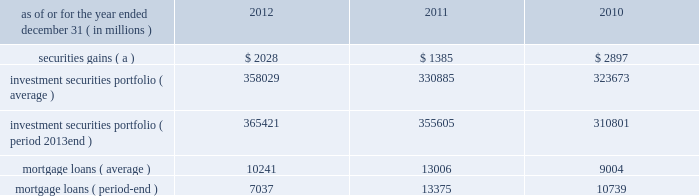Jpmorgan chase & co./2012 annual report 103 2011 compared with 2010 net income was $ 822 million , compared with $ 1.3 billion in the prior year .
Private equity reported net income of $ 391 million , compared with $ 588 million in the prior year .
Net revenue was $ 836 million , a decrease of $ 403 million , primarily related to net write-downs on private investments and the absence of prior year gains on sales .
Noninterest expense was $ 238 million , a decrease of $ 85 million from the prior treasury and cio reported net income of $ 1.3 billion , compared with net income of $ 3.6 billion in the prior year .
Net revenue was $ 3.2 billion , including $ 1.4 billion of security gains .
Net interest income in 2011 was lower compared with 2010 , primarily driven by repositioning of the investment securities portfolio and lower funding benefits from financing the portfolio .
Other corporate reported a net loss of $ 918 million , compared with a net loss of $ 2.9 billion in the prior year .
Net revenue was $ 103 million , compared with a net loss of $ 467 million in the prior year .
Noninterest expense was $ 2.9 billion which included $ 3.2 billion of additional litigation reserves , predominantly for mortgage-related matters .
Noninterest expense in the prior year was $ 5.5 billion which included $ 5.7 billion of additional litigation reserves .
Treasury and cio overview treasury and cio are predominantly responsible for measuring , monitoring , reporting and managing the firm 2019s liquidity , funding , capital and structural interest rate and foreign exchange risks .
The risks managed by treasury and cio arise from the activities undertaken by the firm 2019s four major reportable business segments to serve their respective client bases , which generate both on- and off- balance sheet assets and liabilities .
Treasury is responsible for , among other functions , funds transfer pricing .
Funds transfer pricing is used to transfer structural interest rate risk and foreign exchange risk of the firm to treasury and cio and allocate interest income and expense to each business based on market rates .
Cio , through its management of the investment portfolio , generates net interest income to pay the lines of business market rates .
Any variance ( whether positive or negative ) between amounts generated by cio through its investment portfolio activities and amounts paid to or received by the lines of business are retained by cio , and are not reflected in line of business segment results .
Treasury and cio activities operate in support of the overall firm .
Cio achieves the firm 2019s asset-liability management objectives generally by investing in high-quality securities that are managed for the longer-term as part of the firm 2019s afs investment portfolio .
Unrealized gains and losses on securities held in the afs portfolio are recorded in other comprehensive income .
For further information about securities in the afs portfolio , see note 3 and note 12 on pages 196 2013214 and 244 2013248 , respectively , of this annual report .
Cio also uses securities that are not classified within the afs portfolio , as well as derivatives , to meet the firm 2019s asset-liability management objectives .
Securities not classified within the afs portfolio are recorded in trading assets and liabilities ; realized and unrealized gains and losses on such securities are recorded in the principal transactions revenue line in the consolidated statements of income .
For further information about securities included in trading assets and liabilities , see note 3 on pages 196 2013214 of this annual report .
Derivatives used by cio are also classified as trading assets and liabilities .
For further information on derivatives , including the classification of realized and unrealized gains and losses , see note 6 on pages 218 2013227 of this annual report .
Cio 2019s afs portfolio consists of u.s .
And non-u.s .
Government securities , agency and non-agency mortgage-backed securities , other asset-backed securities and corporate and municipal debt securities .
Treasury 2019s afs portfolio consists of u.s .
And non-u.s .
Government securities and corporate debt securities .
At december 31 , 2012 , the total treasury and cio afs portfolios were $ 344.1 billion and $ 21.3 billion , respectively ; the average credit rating of the securities comprising the treasury and cio afs portfolios was aa+ ( based upon external ratings where available and where not available , based primarily upon internal ratings that correspond to ratings as defined by s&p and moody 2019s ) .
See note 12 on pages 244 2013248 of this annual report for further information on the details of the firm 2019s afs portfolio .
For further information on liquidity and funding risk , see liquidity risk management on pages 127 2013133 of this annual report .
For information on interest rate , foreign exchange and other risks , and cio var and the firm 2019s nontrading interest rate-sensitive revenue at risk , see market risk management on pages 163 2013169 of this annual report .
Selected income statement and balance sheet data as of or for the year ended december 31 , ( in millions ) 2012 2011 2010 securities gains ( a ) $ 2028 $ 1385 $ 2897 investment securities portfolio ( average ) 358029 330885 323673 investment securities portfolio ( period 2013end ) 365421 355605 310801 .
( a ) reflects repositioning of the investment securities portfolio. .
What was the private equity bussiness arm's 2011 efficiency ratio? 
Computations: (238 / 836)
Answer: 0.28469. Jpmorgan chase & co./2012 annual report 103 2011 compared with 2010 net income was $ 822 million , compared with $ 1.3 billion in the prior year .
Private equity reported net income of $ 391 million , compared with $ 588 million in the prior year .
Net revenue was $ 836 million , a decrease of $ 403 million , primarily related to net write-downs on private investments and the absence of prior year gains on sales .
Noninterest expense was $ 238 million , a decrease of $ 85 million from the prior treasury and cio reported net income of $ 1.3 billion , compared with net income of $ 3.6 billion in the prior year .
Net revenue was $ 3.2 billion , including $ 1.4 billion of security gains .
Net interest income in 2011 was lower compared with 2010 , primarily driven by repositioning of the investment securities portfolio and lower funding benefits from financing the portfolio .
Other corporate reported a net loss of $ 918 million , compared with a net loss of $ 2.9 billion in the prior year .
Net revenue was $ 103 million , compared with a net loss of $ 467 million in the prior year .
Noninterest expense was $ 2.9 billion which included $ 3.2 billion of additional litigation reserves , predominantly for mortgage-related matters .
Noninterest expense in the prior year was $ 5.5 billion which included $ 5.7 billion of additional litigation reserves .
Treasury and cio overview treasury and cio are predominantly responsible for measuring , monitoring , reporting and managing the firm 2019s liquidity , funding , capital and structural interest rate and foreign exchange risks .
The risks managed by treasury and cio arise from the activities undertaken by the firm 2019s four major reportable business segments to serve their respective client bases , which generate both on- and off- balance sheet assets and liabilities .
Treasury is responsible for , among other functions , funds transfer pricing .
Funds transfer pricing is used to transfer structural interest rate risk and foreign exchange risk of the firm to treasury and cio and allocate interest income and expense to each business based on market rates .
Cio , through its management of the investment portfolio , generates net interest income to pay the lines of business market rates .
Any variance ( whether positive or negative ) between amounts generated by cio through its investment portfolio activities and amounts paid to or received by the lines of business are retained by cio , and are not reflected in line of business segment results .
Treasury and cio activities operate in support of the overall firm .
Cio achieves the firm 2019s asset-liability management objectives generally by investing in high-quality securities that are managed for the longer-term as part of the firm 2019s afs investment portfolio .
Unrealized gains and losses on securities held in the afs portfolio are recorded in other comprehensive income .
For further information about securities in the afs portfolio , see note 3 and note 12 on pages 196 2013214 and 244 2013248 , respectively , of this annual report .
Cio also uses securities that are not classified within the afs portfolio , as well as derivatives , to meet the firm 2019s asset-liability management objectives .
Securities not classified within the afs portfolio are recorded in trading assets and liabilities ; realized and unrealized gains and losses on such securities are recorded in the principal transactions revenue line in the consolidated statements of income .
For further information about securities included in trading assets and liabilities , see note 3 on pages 196 2013214 of this annual report .
Derivatives used by cio are also classified as trading assets and liabilities .
For further information on derivatives , including the classification of realized and unrealized gains and losses , see note 6 on pages 218 2013227 of this annual report .
Cio 2019s afs portfolio consists of u.s .
And non-u.s .
Government securities , agency and non-agency mortgage-backed securities , other asset-backed securities and corporate and municipal debt securities .
Treasury 2019s afs portfolio consists of u.s .
And non-u.s .
Government securities and corporate debt securities .
At december 31 , 2012 , the total treasury and cio afs portfolios were $ 344.1 billion and $ 21.3 billion , respectively ; the average credit rating of the securities comprising the treasury and cio afs portfolios was aa+ ( based upon external ratings where available and where not available , based primarily upon internal ratings that correspond to ratings as defined by s&p and moody 2019s ) .
See note 12 on pages 244 2013248 of this annual report for further information on the details of the firm 2019s afs portfolio .
For further information on liquidity and funding risk , see liquidity risk management on pages 127 2013133 of this annual report .
For information on interest rate , foreign exchange and other risks , and cio var and the firm 2019s nontrading interest rate-sensitive revenue at risk , see market risk management on pages 163 2013169 of this annual report .
Selected income statement and balance sheet data as of or for the year ended december 31 , ( in millions ) 2012 2011 2010 securities gains ( a ) $ 2028 $ 1385 $ 2897 investment securities portfolio ( average ) 358029 330885 323673 investment securities portfolio ( period 2013end ) 365421 355605 310801 .
( a ) reflects repositioning of the investment securities portfolio. .
In 2012 what percentage of the investment securities portfolio consited of mortgage loans? 
Computations: (7037 / 365421)
Answer: 0.01926. Jpmorgan chase & co./2012 annual report 103 2011 compared with 2010 net income was $ 822 million , compared with $ 1.3 billion in the prior year .
Private equity reported net income of $ 391 million , compared with $ 588 million in the prior year .
Net revenue was $ 836 million , a decrease of $ 403 million , primarily related to net write-downs on private investments and the absence of prior year gains on sales .
Noninterest expense was $ 238 million , a decrease of $ 85 million from the prior treasury and cio reported net income of $ 1.3 billion , compared with net income of $ 3.6 billion in the prior year .
Net revenue was $ 3.2 billion , including $ 1.4 billion of security gains .
Net interest income in 2011 was lower compared with 2010 , primarily driven by repositioning of the investment securities portfolio and lower funding benefits from financing the portfolio .
Other corporate reported a net loss of $ 918 million , compared with a net loss of $ 2.9 billion in the prior year .
Net revenue was $ 103 million , compared with a net loss of $ 467 million in the prior year .
Noninterest expense was $ 2.9 billion which included $ 3.2 billion of additional litigation reserves , predominantly for mortgage-related matters .
Noninterest expense in the prior year was $ 5.5 billion which included $ 5.7 billion of additional litigation reserves .
Treasury and cio overview treasury and cio are predominantly responsible for measuring , monitoring , reporting and managing the firm 2019s liquidity , funding , capital and structural interest rate and foreign exchange risks .
The risks managed by treasury and cio arise from the activities undertaken by the firm 2019s four major reportable business segments to serve their respective client bases , which generate both on- and off- balance sheet assets and liabilities .
Treasury is responsible for , among other functions , funds transfer pricing .
Funds transfer pricing is used to transfer structural interest rate risk and foreign exchange risk of the firm to treasury and cio and allocate interest income and expense to each business based on market rates .
Cio , through its management of the investment portfolio , generates net interest income to pay the lines of business market rates .
Any variance ( whether positive or negative ) between amounts generated by cio through its investment portfolio activities and amounts paid to or received by the lines of business are retained by cio , and are not reflected in line of business segment results .
Treasury and cio activities operate in support of the overall firm .
Cio achieves the firm 2019s asset-liability management objectives generally by investing in high-quality securities that are managed for the longer-term as part of the firm 2019s afs investment portfolio .
Unrealized gains and losses on securities held in the afs portfolio are recorded in other comprehensive income .
For further information about securities in the afs portfolio , see note 3 and note 12 on pages 196 2013214 and 244 2013248 , respectively , of this annual report .
Cio also uses securities that are not classified within the afs portfolio , as well as derivatives , to meet the firm 2019s asset-liability management objectives .
Securities not classified within the afs portfolio are recorded in trading assets and liabilities ; realized and unrealized gains and losses on such securities are recorded in the principal transactions revenue line in the consolidated statements of income .
For further information about securities included in trading assets and liabilities , see note 3 on pages 196 2013214 of this annual report .
Derivatives used by cio are also classified as trading assets and liabilities .
For further information on derivatives , including the classification of realized and unrealized gains and losses , see note 6 on pages 218 2013227 of this annual report .
Cio 2019s afs portfolio consists of u.s .
And non-u.s .
Government securities , agency and non-agency mortgage-backed securities , other asset-backed securities and corporate and municipal debt securities .
Treasury 2019s afs portfolio consists of u.s .
And non-u.s .
Government securities and corporate debt securities .
At december 31 , 2012 , the total treasury and cio afs portfolios were $ 344.1 billion and $ 21.3 billion , respectively ; the average credit rating of the securities comprising the treasury and cio afs portfolios was aa+ ( based upon external ratings where available and where not available , based primarily upon internal ratings that correspond to ratings as defined by s&p and moody 2019s ) .
See note 12 on pages 244 2013248 of this annual report for further information on the details of the firm 2019s afs portfolio .
For further information on liquidity and funding risk , see liquidity risk management on pages 127 2013133 of this annual report .
For information on interest rate , foreign exchange and other risks , and cio var and the firm 2019s nontrading interest rate-sensitive revenue at risk , see market risk management on pages 163 2013169 of this annual report .
Selected income statement and balance sheet data as of or for the year ended december 31 , ( in millions ) 2012 2011 2010 securities gains ( a ) $ 2028 $ 1385 $ 2897 investment securities portfolio ( average ) 358029 330885 323673 investment securities portfolio ( period 2013end ) 365421 355605 310801 .
( a ) reflects repositioning of the investment securities portfolio. .
In 2012 what was the ratio of the mortgage loans ( average ) to mortgage loans ( period-end ) \\n? 
Computations: (10241 / 7037)
Answer: 1.45531. Jpmorgan chase & co./2012 annual report 103 2011 compared with 2010 net income was $ 822 million , compared with $ 1.3 billion in the prior year .
Private equity reported net income of $ 391 million , compared with $ 588 million in the prior year .
Net revenue was $ 836 million , a decrease of $ 403 million , primarily related to net write-downs on private investments and the absence of prior year gains on sales .
Noninterest expense was $ 238 million , a decrease of $ 85 million from the prior treasury and cio reported net income of $ 1.3 billion , compared with net income of $ 3.6 billion in the prior year .
Net revenue was $ 3.2 billion , including $ 1.4 billion of security gains .
Net interest income in 2011 was lower compared with 2010 , primarily driven by repositioning of the investment securities portfolio and lower funding benefits from financing the portfolio .
Other corporate reported a net loss of $ 918 million , compared with a net loss of $ 2.9 billion in the prior year .
Net revenue was $ 103 million , compared with a net loss of $ 467 million in the prior year .
Noninterest expense was $ 2.9 billion which included $ 3.2 billion of additional litigation reserves , predominantly for mortgage-related matters .
Noninterest expense in the prior year was $ 5.5 billion which included $ 5.7 billion of additional litigation reserves .
Treasury and cio overview treasury and cio are predominantly responsible for measuring , monitoring , reporting and managing the firm 2019s liquidity , funding , capital and structural interest rate and foreign exchange risks .
The risks managed by treasury and cio arise from the activities undertaken by the firm 2019s four major reportable business segments to serve their respective client bases , which generate both on- and off- balance sheet assets and liabilities .
Treasury is responsible for , among other functions , funds transfer pricing .
Funds transfer pricing is used to transfer structural interest rate risk and foreign exchange risk of the firm to treasury and cio and allocate interest income and expense to each business based on market rates .
Cio , through its management of the investment portfolio , generates net interest income to pay the lines of business market rates .
Any variance ( whether positive or negative ) between amounts generated by cio through its investment portfolio activities and amounts paid to or received by the lines of business are retained by cio , and are not reflected in line of business segment results .
Treasury and cio activities operate in support of the overall firm .
Cio achieves the firm 2019s asset-liability management objectives generally by investing in high-quality securities that are managed for the longer-term as part of the firm 2019s afs investment portfolio .
Unrealized gains and losses on securities held in the afs portfolio are recorded in other comprehensive income .
For further information about securities in the afs portfolio , see note 3 and note 12 on pages 196 2013214 and 244 2013248 , respectively , of this annual report .
Cio also uses securities that are not classified within the afs portfolio , as well as derivatives , to meet the firm 2019s asset-liability management objectives .
Securities not classified within the afs portfolio are recorded in trading assets and liabilities ; realized and unrealized gains and losses on such securities are recorded in the principal transactions revenue line in the consolidated statements of income .
For further information about securities included in trading assets and liabilities , see note 3 on pages 196 2013214 of this annual report .
Derivatives used by cio are also classified as trading assets and liabilities .
For further information on derivatives , including the classification of realized and unrealized gains and losses , see note 6 on pages 218 2013227 of this annual report .
Cio 2019s afs portfolio consists of u.s .
And non-u.s .
Government securities , agency and non-agency mortgage-backed securities , other asset-backed securities and corporate and municipal debt securities .
Treasury 2019s afs portfolio consists of u.s .
And non-u.s .
Government securities and corporate debt securities .
At december 31 , 2012 , the total treasury and cio afs portfolios were $ 344.1 billion and $ 21.3 billion , respectively ; the average credit rating of the securities comprising the treasury and cio afs portfolios was aa+ ( based upon external ratings where available and where not available , based primarily upon internal ratings that correspond to ratings as defined by s&p and moody 2019s ) .
See note 12 on pages 244 2013248 of this annual report for further information on the details of the firm 2019s afs portfolio .
For further information on liquidity and funding risk , see liquidity risk management on pages 127 2013133 of this annual report .
For information on interest rate , foreign exchange and other risks , and cio var and the firm 2019s nontrading interest rate-sensitive revenue at risk , see market risk management on pages 163 2013169 of this annual report .
Selected income statement and balance sheet data as of or for the year ended december 31 , ( in millions ) 2012 2011 2010 securities gains ( a ) $ 2028 $ 1385 $ 2897 investment securities portfolio ( average ) 358029 330885 323673 investment securities portfolio ( period 2013end ) 365421 355605 310801 .
( a ) reflects repositioning of the investment securities portfolio. .
What was the year over year change in the change in litigation reserves , in billions? 
Computations: (5.7 - 3.2)
Answer: 2.5. 